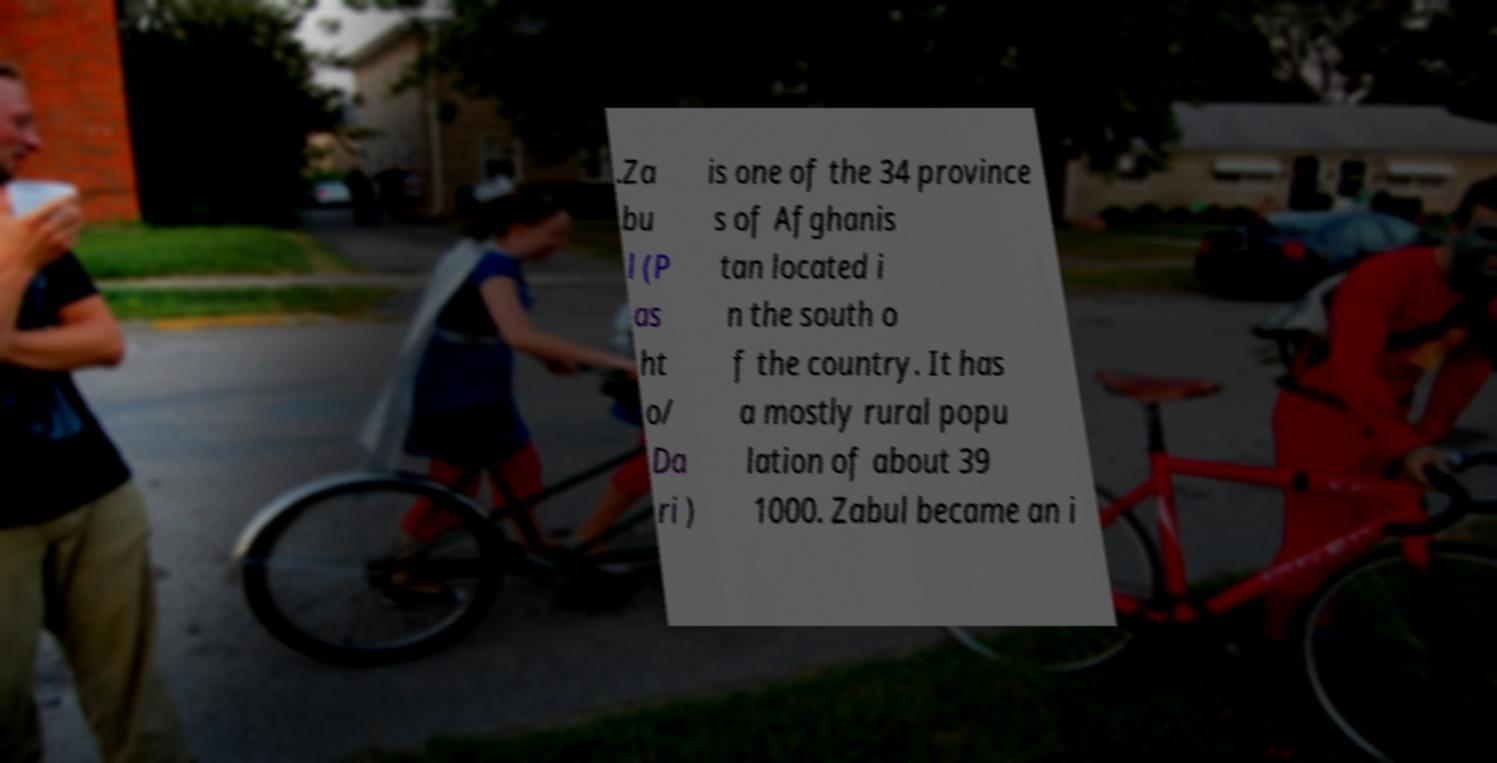There's text embedded in this image that I need extracted. Can you transcribe it verbatim? .Za bu l (P as ht o/ Da ri ) is one of the 34 province s of Afghanis tan located i n the south o f the country. It has a mostly rural popu lation of about 39 1000. Zabul became an i 